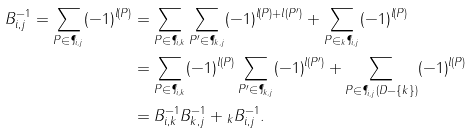Convert formula to latex. <formula><loc_0><loc_0><loc_500><loc_500>B _ { i , j } ^ { - 1 } = \sum _ { P \in \P _ { i , j } } ( - 1 ) ^ { l ( P ) } & = \sum _ { P \in \P _ { i , k } } \sum _ { P ^ { \prime } \in \P _ { k , j } } ( - 1 ) ^ { l ( P ) + l ( P ^ { \prime } ) } + \sum _ { P \in { _ { k } } \P _ { i , j } } ( - 1 ) ^ { l ( P ) } \\ & = \sum _ { P \in \P _ { i , k } } ( - 1 ) ^ { l ( P ) } \sum _ { P ^ { \prime } \in \P _ { k , j } } ( - 1 ) ^ { l ( P ^ { \prime } ) } + \sum _ { P \in \P _ { i , j } ( D - \{ k \} ) } ( - 1 ) ^ { l ( P ) } \\ & = B _ { i , k } ^ { - 1 } B _ { k , j } ^ { - 1 } + { _ { k } } B _ { i , j } ^ { - 1 } .</formula> 